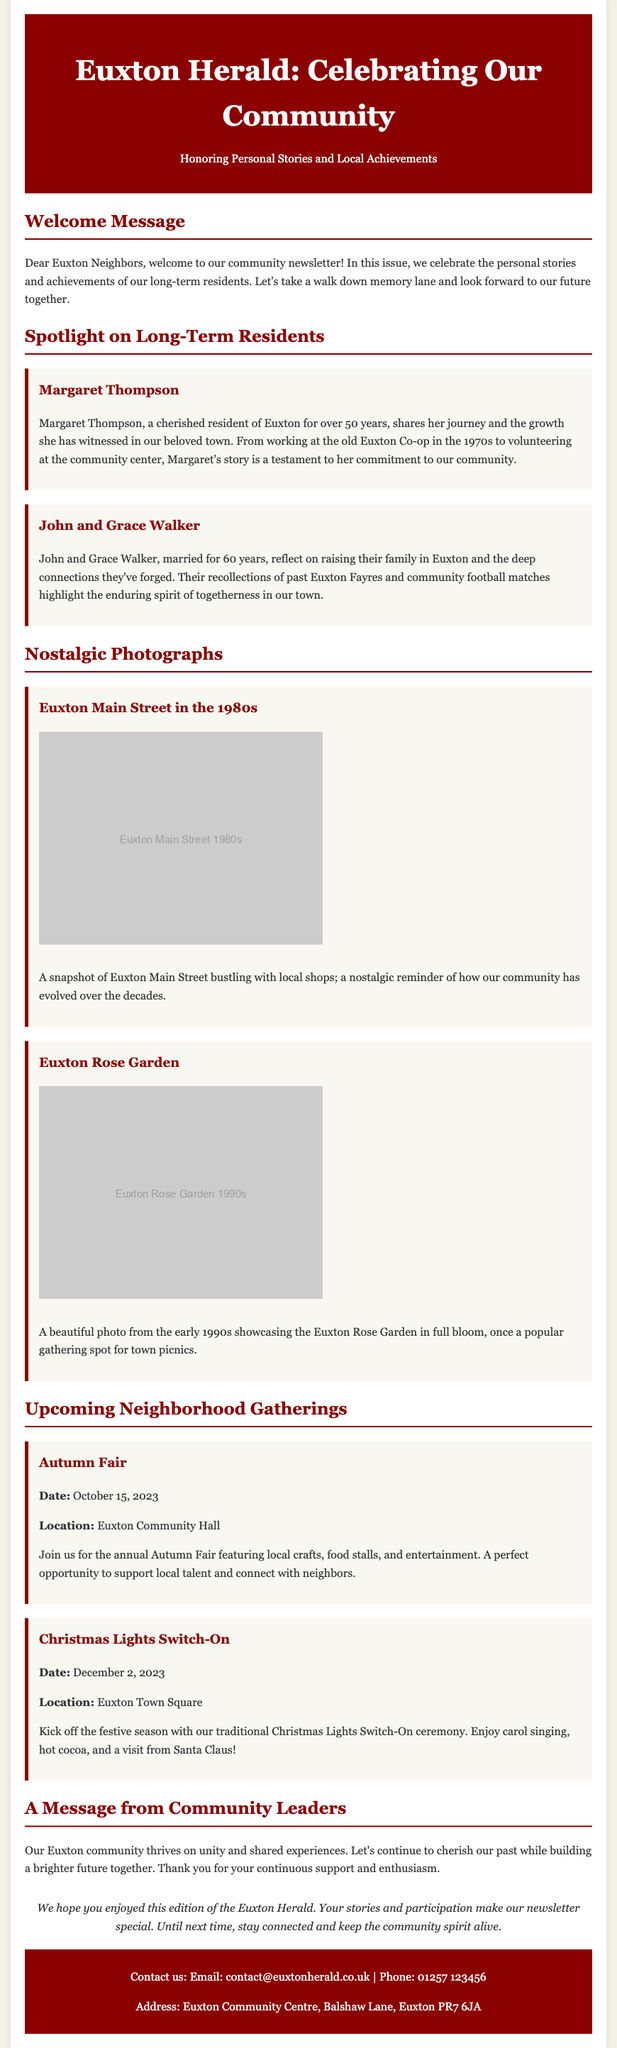What is the title of the newsletter? The title is prominently displayed in the header section of the document.
Answer: Euxton Herald: Celebrating Our Community Who shares their journey in the newsletter? The newsletter highlights the stories of residents, specifically mentioning two individuals.
Answer: Margaret Thompson How many years have John and Grace Walker been married? Their marriage duration is explicitly mentioned in their spotlight section.
Answer: 60 years What is the date of the Autumn Fair? The date is provided in the upcoming events section.
Answer: October 15, 2023 What is the main color used in the header background? The header background color is specifically utilized to grab attention.
Answer: Dark red What does the message from community leaders emphasize? This message reflects a broader theme present in the document relating to community values.
Answer: Unity In which location is the Christmas Lights Switch-On taking place? The location is designated for the event and is mentioned in its description.
Answer: Euxton Town Square What type of content does the newsletter celebrate? The overarching theme of the newsletter is centered on specific achievements and memories.
Answer: Personal stories and local achievements 